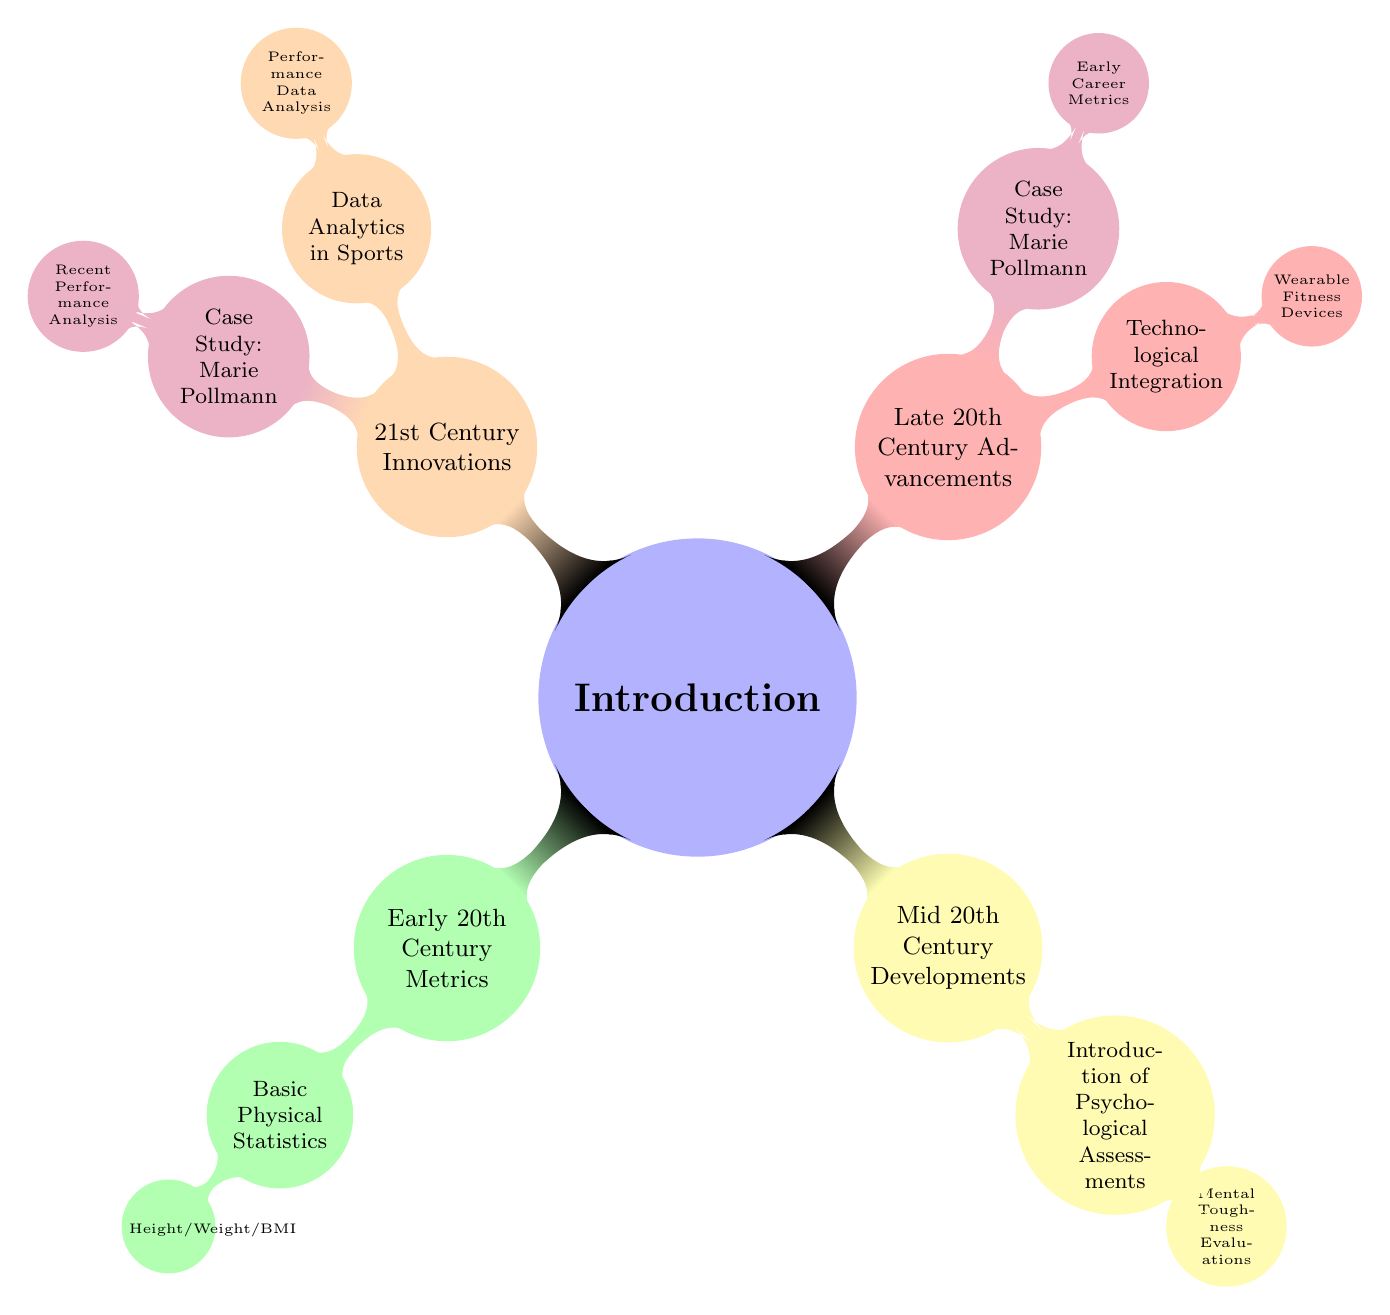What is the primary focus of the diagram? The primary focus is on the evolution of human performance metrics in female athletes, as indicated by the title and the structure of top-level nodes which outline various periods and advancements in metrics.
Answer: evolution of human performance metrics in female athletes How many main periods are represented in the diagram? The diagram consists of four main periods: Early 20th Century Metrics, Mid 20th Century Developments, Late 20th Century Advancements, and 21st Century Innovations. This can be determined by counting the top-level child nodes under the "Introduction" node.
Answer: four What child node is associated with the case study of Marie Pollmann in the late 20th century? The child node associated with the case study of Marie Pollmann in the late 20th century is "Early Career Metrics." This can be identified under the "Case Study: Marie Pollmann" node, which branches from "Late 20th Century Advancements."
Answer: Early Career Metrics Which child node is linked to the introduction of psychological assessments? The child node linked to the introduction of psychological assessments is "Mental Toughness Evaluations." This node is found under the "Introduction of Psychological Assessments" node, which is part of the "Mid 20th Century Developments."
Answer: Mental Toughness Evaluations How does technological integration in the late 20th century relate to the case study of Marie Pollmann? Technological integration, represented by "Wearable Fitness Devices," is a parallel advancement to the case study of Marie Pollmann, which emphasizes her "Early Career Metrics." Both are part of the "Late 20th Century Advancements," illustrating how these advancements can influence individual athlete metrics.
Answer: parallel advancements 